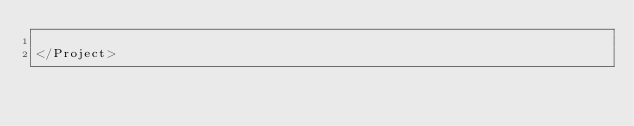Convert code to text. <code><loc_0><loc_0><loc_500><loc_500><_XML_>
</Project>
</code> 